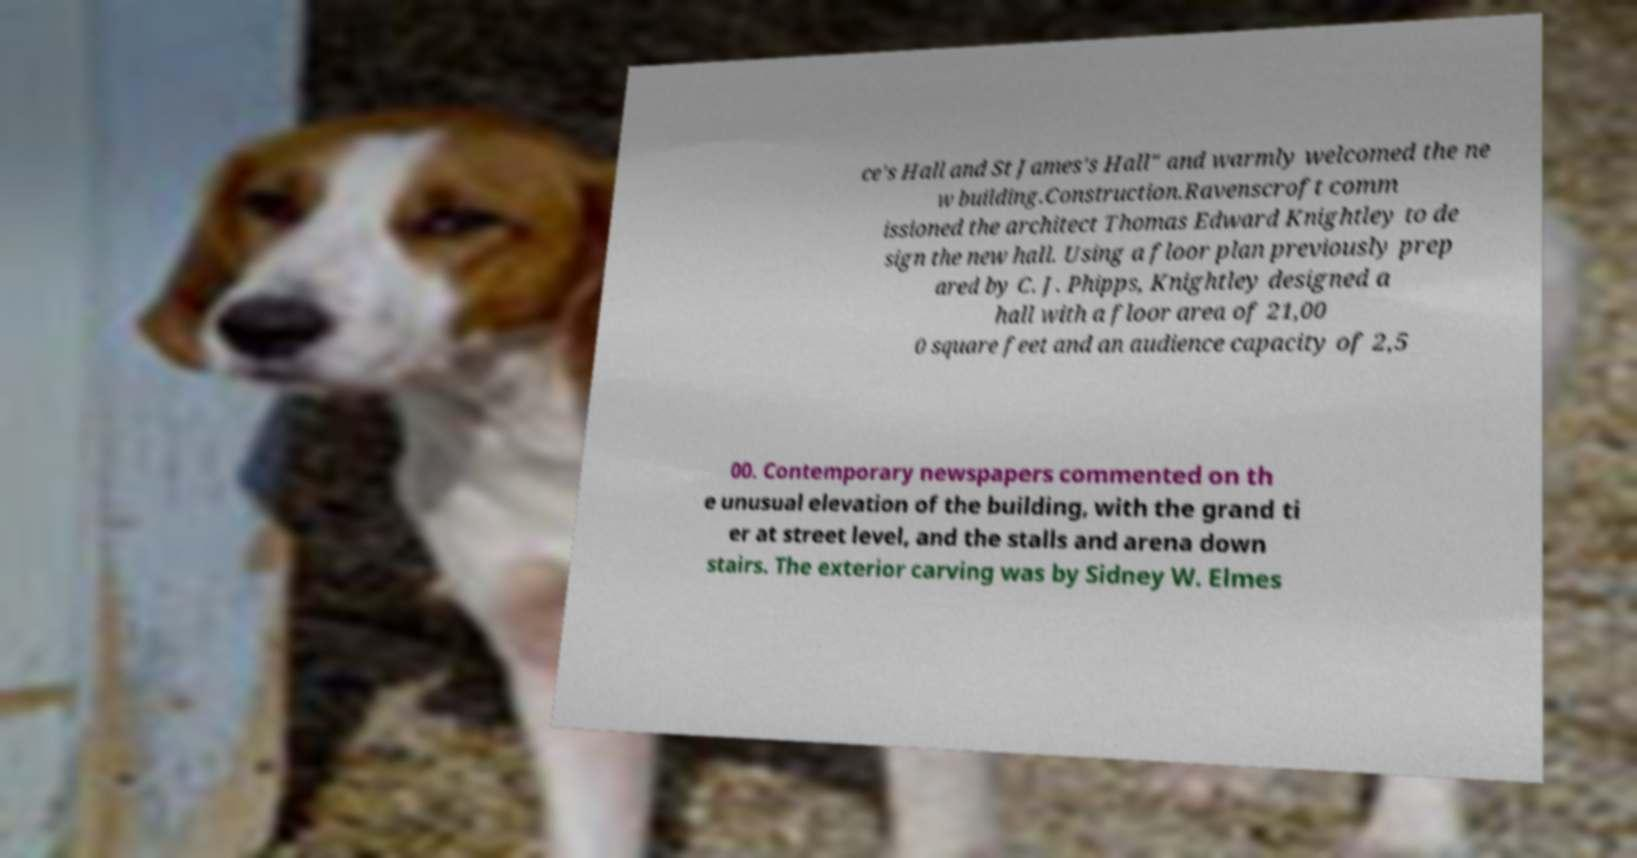For documentation purposes, I need the text within this image transcribed. Could you provide that? ce's Hall and St James's Hall" and warmly welcomed the ne w building.Construction.Ravenscroft comm issioned the architect Thomas Edward Knightley to de sign the new hall. Using a floor plan previously prep ared by C. J. Phipps, Knightley designed a hall with a floor area of 21,00 0 square feet and an audience capacity of 2,5 00. Contemporary newspapers commented on th e unusual elevation of the building, with the grand ti er at street level, and the stalls and arena down stairs. The exterior carving was by Sidney W. Elmes 